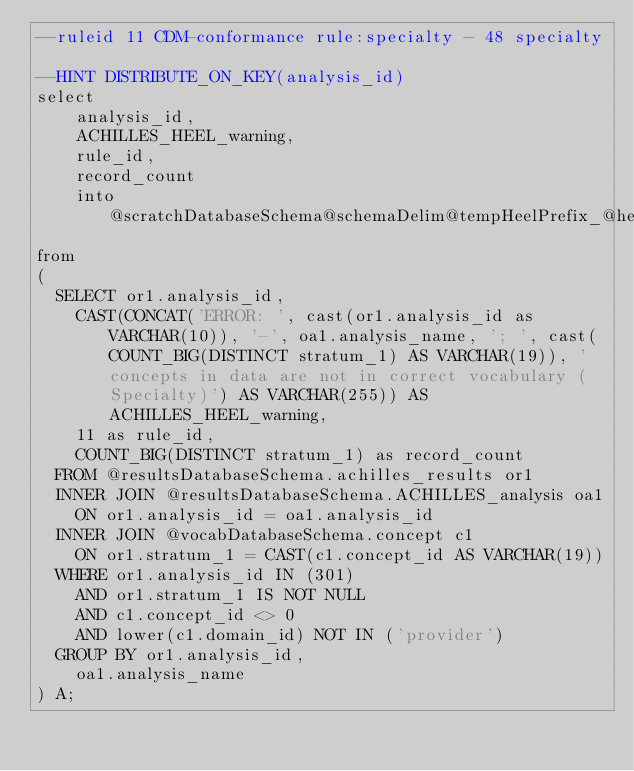Convert code to text. <code><loc_0><loc_0><loc_500><loc_500><_SQL_>--ruleid 11 CDM-conformance rule:specialty - 48 specialty

--HINT DISTRIBUTE_ON_KEY(analysis_id)
select
	analysis_id,
	ACHILLES_HEEL_warning,
	rule_id,
	record_count
	into @scratchDatabaseSchema@schemaDelim@tempHeelPrefix_@heelName
from
(
  SELECT or1.analysis_id,
  	CAST(CONCAT('ERROR: ', cast(or1.analysis_id as VARCHAR(10)), '-', oa1.analysis_name, '; ', cast(COUNT_BIG(DISTINCT stratum_1) AS VARCHAR(19)), ' concepts in data are not in correct vocabulary (Specialty)') AS VARCHAR(255)) AS ACHILLES_HEEL_warning,
    11 as rule_id,
    COUNT_BIG(DISTINCT stratum_1) as record_count
  FROM @resultsDatabaseSchema.achilles_results or1
  INNER JOIN @resultsDatabaseSchema.ACHILLES_analysis oa1
  	ON or1.analysis_id = oa1.analysis_id
  INNER JOIN @vocabDatabaseSchema.concept c1
  	ON or1.stratum_1 = CAST(c1.concept_id AS VARCHAR(19))
  WHERE or1.analysis_id IN (301)
  	AND or1.stratum_1 IS NOT NULL
  	AND c1.concept_id <> 0 
    AND lower(c1.domain_id) NOT IN ('provider')
  GROUP BY or1.analysis_id,
  	oa1.analysis_name
) A;
</code> 